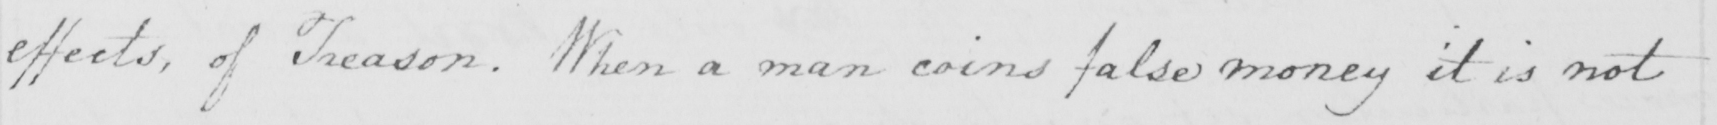Transcribe the text shown in this historical manuscript line. effects , of Treason . When a man coins false money it is not 